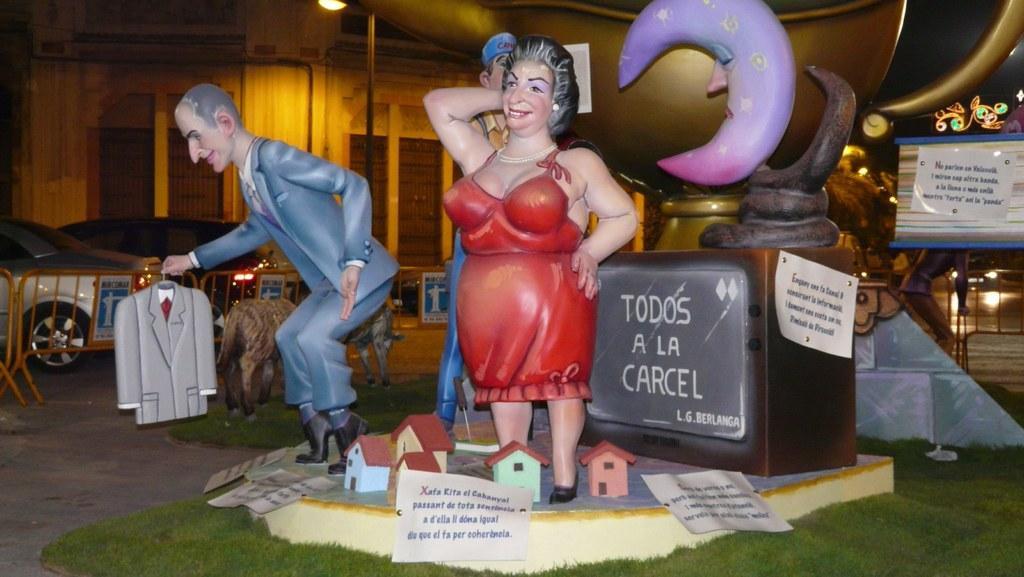Can you describe this image briefly? In this picture there are miniatures. In the foreground there is a woman standing and there is a man standing and holding and the suit and there is another man standing and there are houses and there are papers and there is text on the papers. At the back there are animals standing on the grass and there is a railing. Behind the railing there are vehicles on the road and there is a building and there is a street light. At the bottom there is a road and there is grass. 